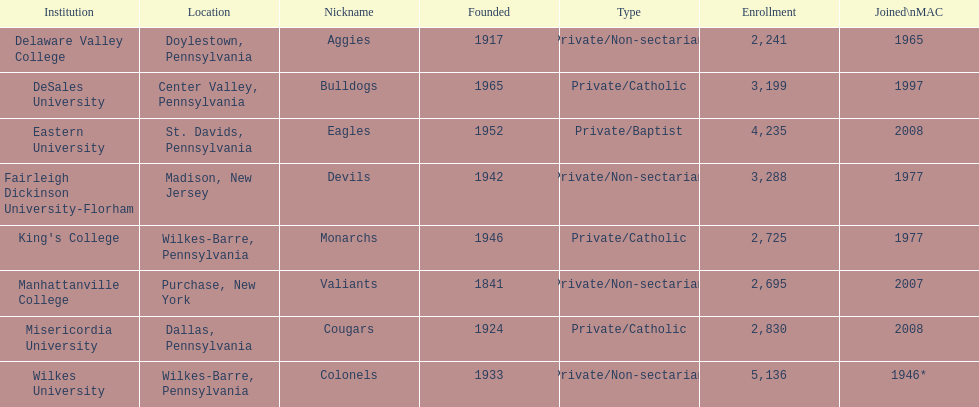What is the admission number of misericordia university? 2,830. 